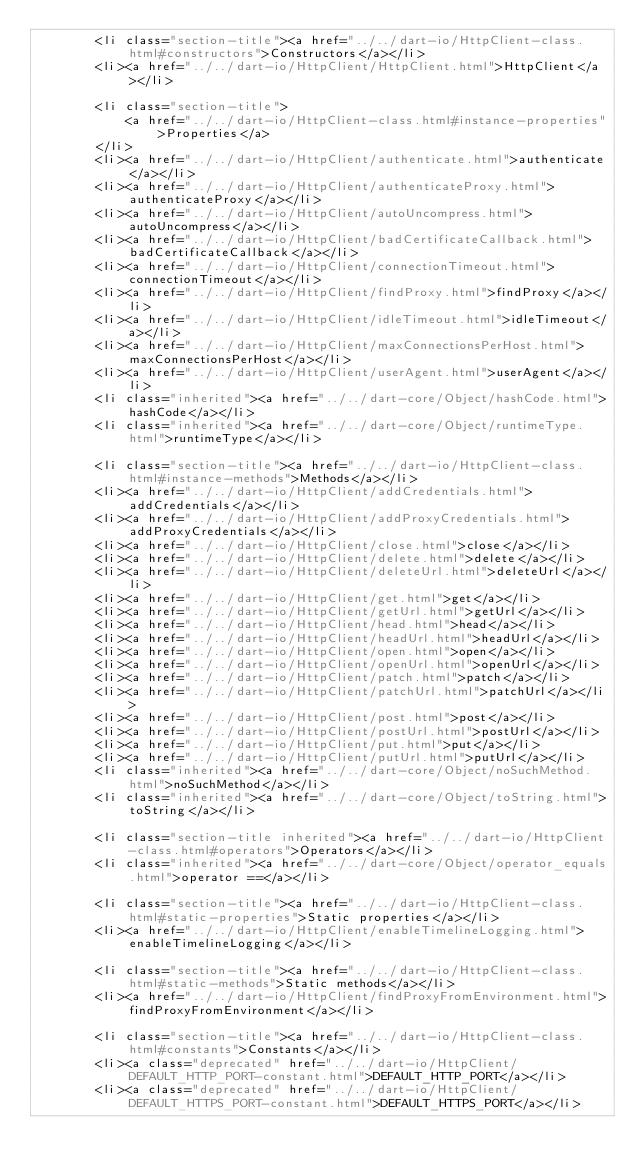Convert code to text. <code><loc_0><loc_0><loc_500><loc_500><_HTML_>        <li class="section-title"><a href="../../dart-io/HttpClient-class.html#constructors">Constructors</a></li>
        <li><a href="../../dart-io/HttpClient/HttpClient.html">HttpClient</a></li>
    
        <li class="section-title">
            <a href="../../dart-io/HttpClient-class.html#instance-properties">Properties</a>
        </li>
        <li><a href="../../dart-io/HttpClient/authenticate.html">authenticate</a></li>
        <li><a href="../../dart-io/HttpClient/authenticateProxy.html">authenticateProxy</a></li>
        <li><a href="../../dart-io/HttpClient/autoUncompress.html">autoUncompress</a></li>
        <li><a href="../../dart-io/HttpClient/badCertificateCallback.html">badCertificateCallback</a></li>
        <li><a href="../../dart-io/HttpClient/connectionTimeout.html">connectionTimeout</a></li>
        <li><a href="../../dart-io/HttpClient/findProxy.html">findProxy</a></li>
        <li><a href="../../dart-io/HttpClient/idleTimeout.html">idleTimeout</a></li>
        <li><a href="../../dart-io/HttpClient/maxConnectionsPerHost.html">maxConnectionsPerHost</a></li>
        <li><a href="../../dart-io/HttpClient/userAgent.html">userAgent</a></li>
        <li class="inherited"><a href="../../dart-core/Object/hashCode.html">hashCode</a></li>
        <li class="inherited"><a href="../../dart-core/Object/runtimeType.html">runtimeType</a></li>
    
        <li class="section-title"><a href="../../dart-io/HttpClient-class.html#instance-methods">Methods</a></li>
        <li><a href="../../dart-io/HttpClient/addCredentials.html">addCredentials</a></li>
        <li><a href="../../dart-io/HttpClient/addProxyCredentials.html">addProxyCredentials</a></li>
        <li><a href="../../dart-io/HttpClient/close.html">close</a></li>
        <li><a href="../../dart-io/HttpClient/delete.html">delete</a></li>
        <li><a href="../../dart-io/HttpClient/deleteUrl.html">deleteUrl</a></li>
        <li><a href="../../dart-io/HttpClient/get.html">get</a></li>
        <li><a href="../../dart-io/HttpClient/getUrl.html">getUrl</a></li>
        <li><a href="../../dart-io/HttpClient/head.html">head</a></li>
        <li><a href="../../dart-io/HttpClient/headUrl.html">headUrl</a></li>
        <li><a href="../../dart-io/HttpClient/open.html">open</a></li>
        <li><a href="../../dart-io/HttpClient/openUrl.html">openUrl</a></li>
        <li><a href="../../dart-io/HttpClient/patch.html">patch</a></li>
        <li><a href="../../dart-io/HttpClient/patchUrl.html">patchUrl</a></li>
        <li><a href="../../dart-io/HttpClient/post.html">post</a></li>
        <li><a href="../../dart-io/HttpClient/postUrl.html">postUrl</a></li>
        <li><a href="../../dart-io/HttpClient/put.html">put</a></li>
        <li><a href="../../dart-io/HttpClient/putUrl.html">putUrl</a></li>
        <li class="inherited"><a href="../../dart-core/Object/noSuchMethod.html">noSuchMethod</a></li>
        <li class="inherited"><a href="../../dart-core/Object/toString.html">toString</a></li>
    
        <li class="section-title inherited"><a href="../../dart-io/HttpClient-class.html#operators">Operators</a></li>
        <li class="inherited"><a href="../../dart-core/Object/operator_equals.html">operator ==</a></li>
    
        <li class="section-title"><a href="../../dart-io/HttpClient-class.html#static-properties">Static properties</a></li>
        <li><a href="../../dart-io/HttpClient/enableTimelineLogging.html">enableTimelineLogging</a></li>
    
        <li class="section-title"><a href="../../dart-io/HttpClient-class.html#static-methods">Static methods</a></li>
        <li><a href="../../dart-io/HttpClient/findProxyFromEnvironment.html">findProxyFromEnvironment</a></li>
    
        <li class="section-title"><a href="../../dart-io/HttpClient-class.html#constants">Constants</a></li>
        <li><a class="deprecated" href="../../dart-io/HttpClient/DEFAULT_HTTP_PORT-constant.html">DEFAULT_HTTP_PORT</a></li>
        <li><a class="deprecated" href="../../dart-io/HttpClient/DEFAULT_HTTPS_PORT-constant.html">DEFAULT_HTTPS_PORT</a></li></code> 